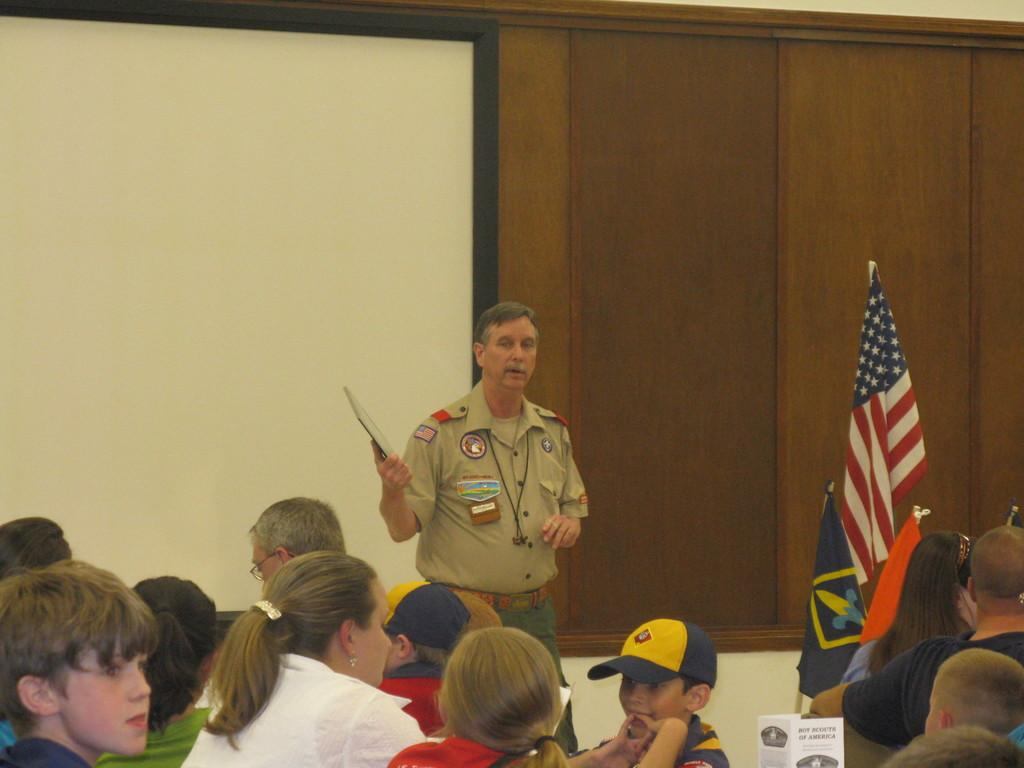What are the people in the image doing? The people in the image are sitting. Can you describe the man in the background of the image? There is a man standing in the background of the image, and he is holding an object. What can be seen in the image besides the people and the man? There are flags and a board visible in the image. Where is the playground located in the image? There is no playground present in the image. What type of trick is the man performing with the object he is holding? The image does not show the man performing any tricks; he is simply holding an object. 